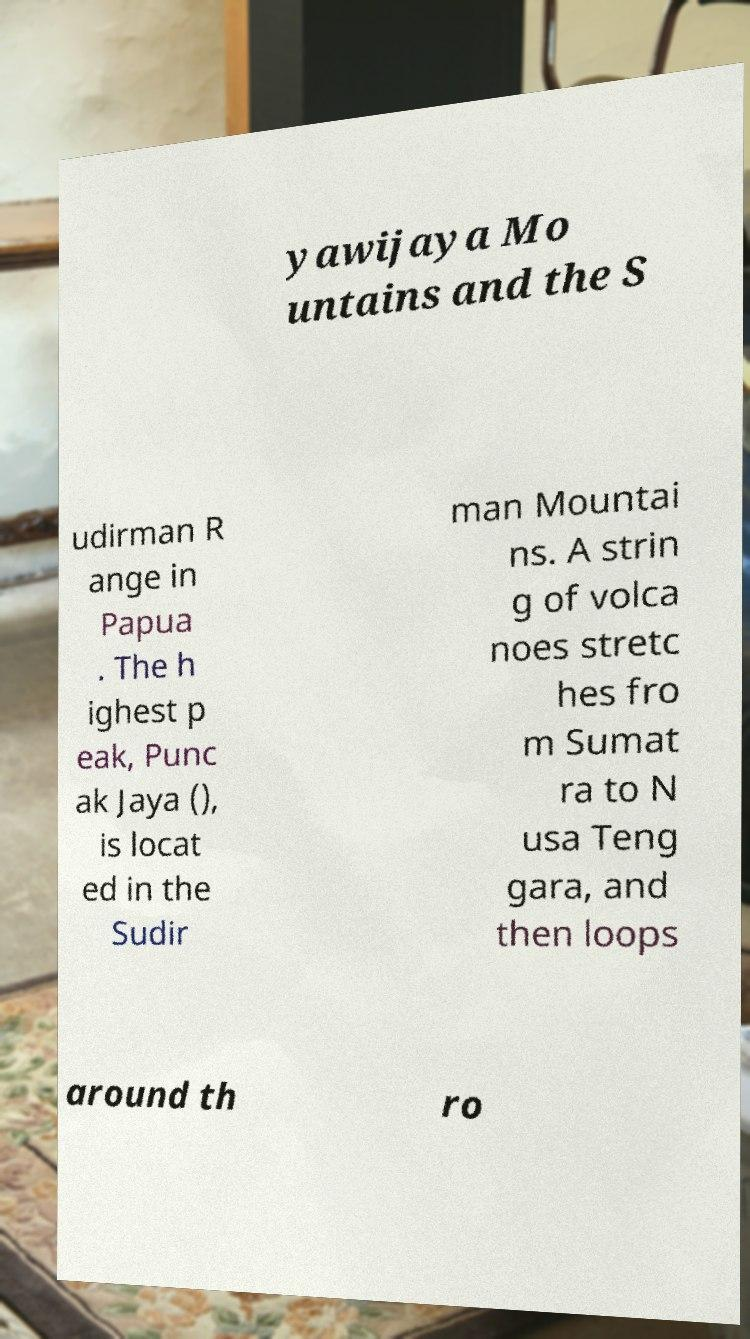Please read and relay the text visible in this image. What does it say? yawijaya Mo untains and the S udirman R ange in Papua . The h ighest p eak, Punc ak Jaya (), is locat ed in the Sudir man Mountai ns. A strin g of volca noes stretc hes fro m Sumat ra to N usa Teng gara, and then loops around th ro 